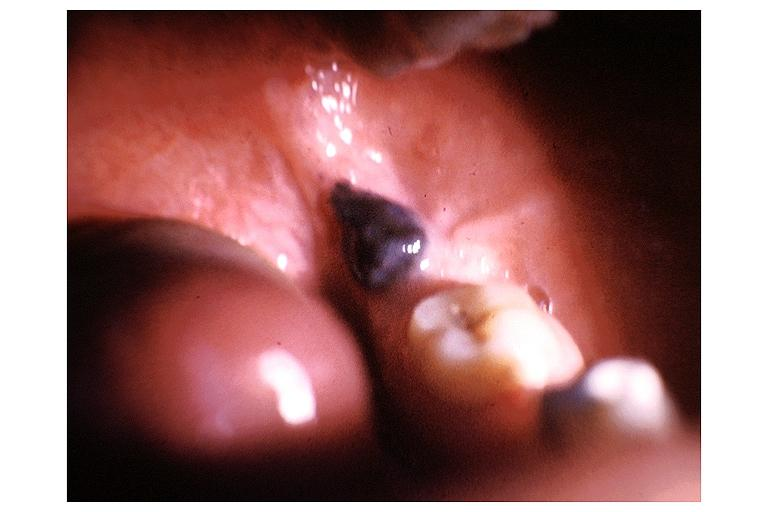what does this image show?
Answer the question using a single word or phrase. Nevus 